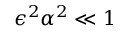<formula> <loc_0><loc_0><loc_500><loc_500>\epsilon ^ { 2 } { \alpha } ^ { 2 } \ll 1</formula> 